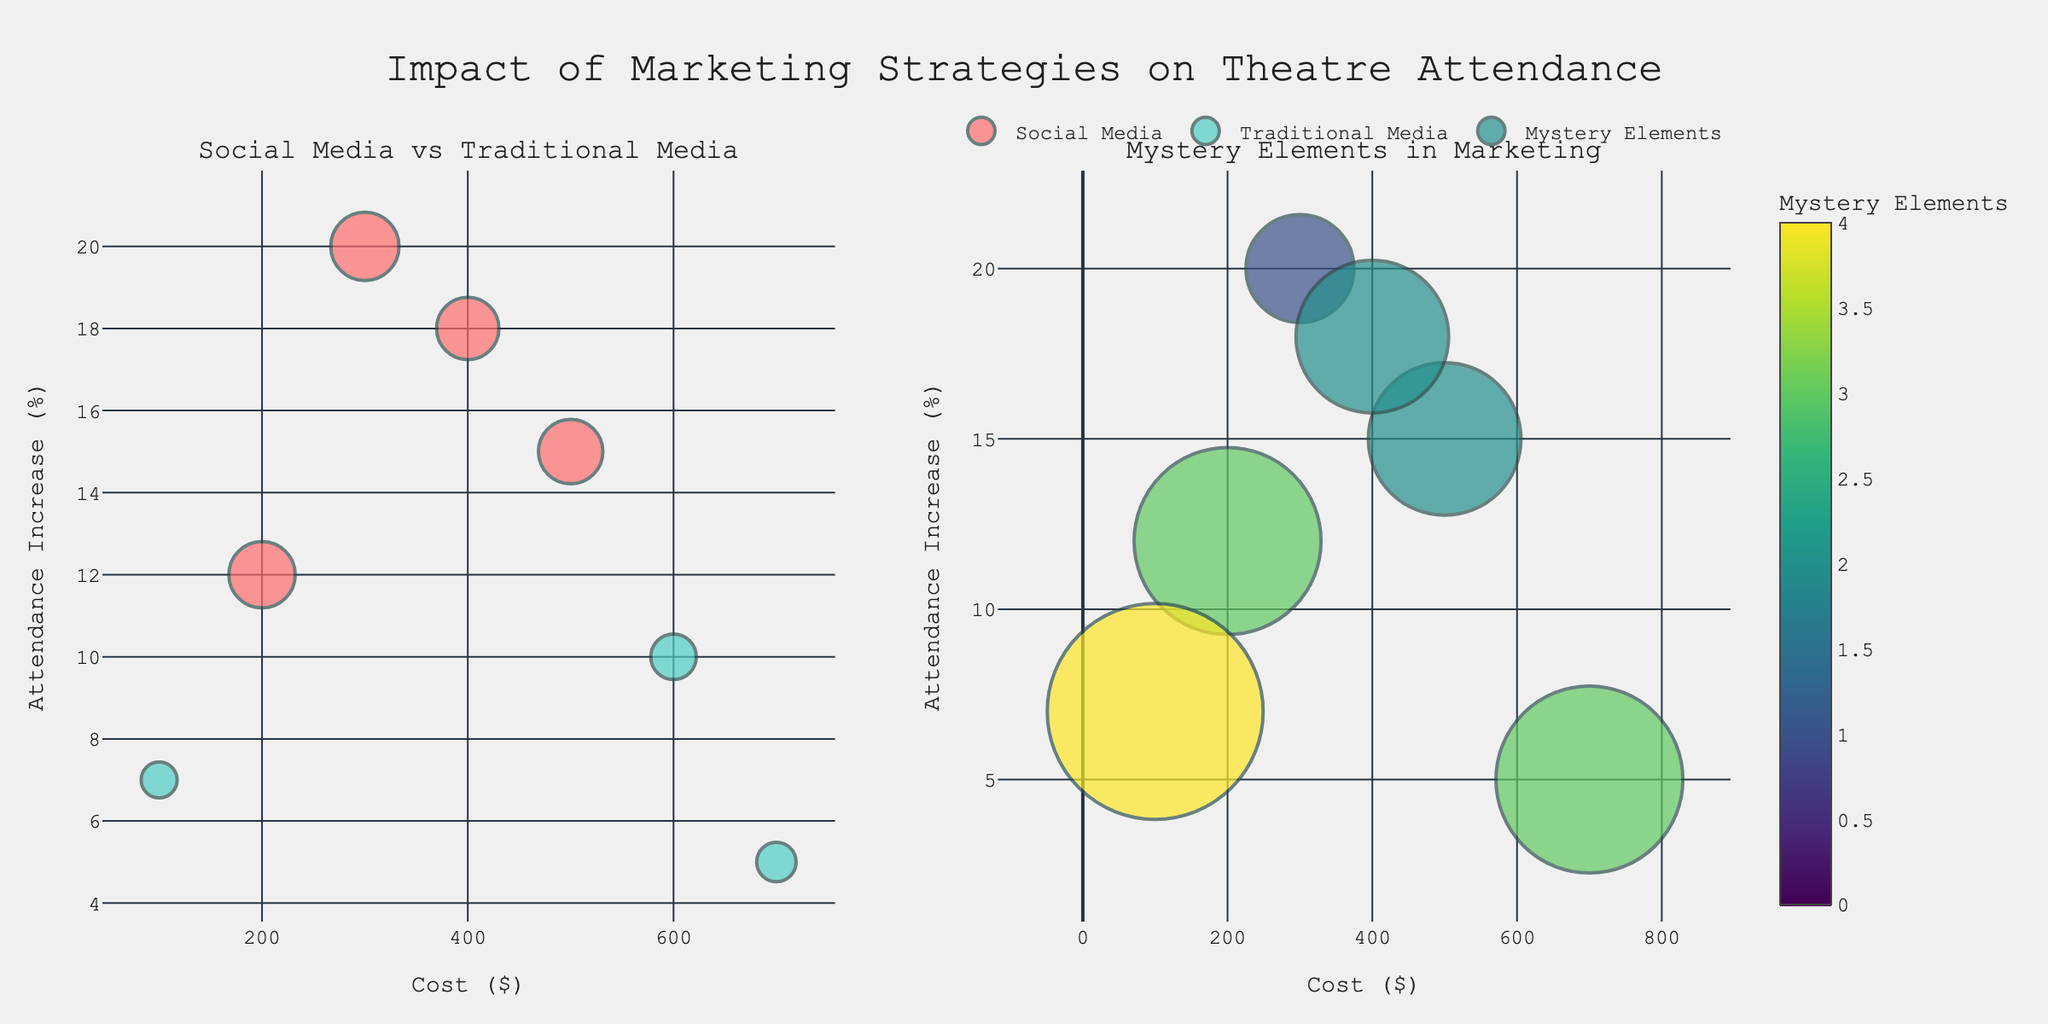What is the title of the plot? The title of the plot is displayed prominently at the top and reads "Impact of Marketing Strategies on Theatre Attendance".
Answer: Impact of Marketing Strategies on Theatre Attendance What is represented by the colors in the first subplot? In the first subplot, colors distinguish between social media and traditional media strategies. Social media is represented in bright red, while traditional media is shown in teal.
Answer: Social media and traditional media strategies Which strategy has the highest increase in attendance and what is its associated cost? From the plot, the strategy with the highest increase in attendance (20%) is "Social Media - Instagram Stories," and the cost associated with this strategy is $300.
Answer: Social Media - Instagram Stories, $300 How is the size of the markers in the first subplot determined? The size of the markers in the first subplot represents the engagement levels of each strategy. Larger markers indicate higher engagement.
Answer: Engagement levels Which marketing strategy has the least engagement and what is its cost? The strategy with the smallest marker in the first subplot (lowest engagement of 25) is "Traditional Media - Community Flyers," with a cost of $100.
Answer: Traditional Media - Community Flyers, $100 What do the colors represent in the second subplot? In the second subplot, colors represent the number of mystery elements used in the marketing strategy. The color bar on the right provides a scale for these values.
Answer: Number of mystery elements Compare the attendance increase between the most and least costly traditional media strategies. The most costly traditional media strategy is "Traditional Media - Local Newspapers" ($700) with a 5% attendance increase. The least costly is "Traditional Media - Community Flyers" ($100) with a 7% attendance increase. Thus, the less costly strategy actually has a higher attendance increase.
Answer: Community Flyers has higher increase What is the relationship between cost and attendance increase for the social media strategies? By observing the plot, social media strategies generally show a trend where higher costs do not necessarily correspond to higher attendance increases. For example, "Instagram Stories" (higher attendance increase) costs less than "Facebook Ads."
Answer: No direct relationship Which strategy combines the highest engagement with a moderate number of mystery elements? "Social Media - Twitter Campaigns" has one of the highest engagement levels (85) and a moderate number of mystery elements (3).
Answer: Social Media - Twitter Campaigns Which traditional media strategy uses the most mystery elements? The strategy "Traditional Media - Community Flyers" utilizes the most mystery elements, indicated by the largest marker in the second subplot and a value of 4.
Answer: Traditional Media - Community Flyers 